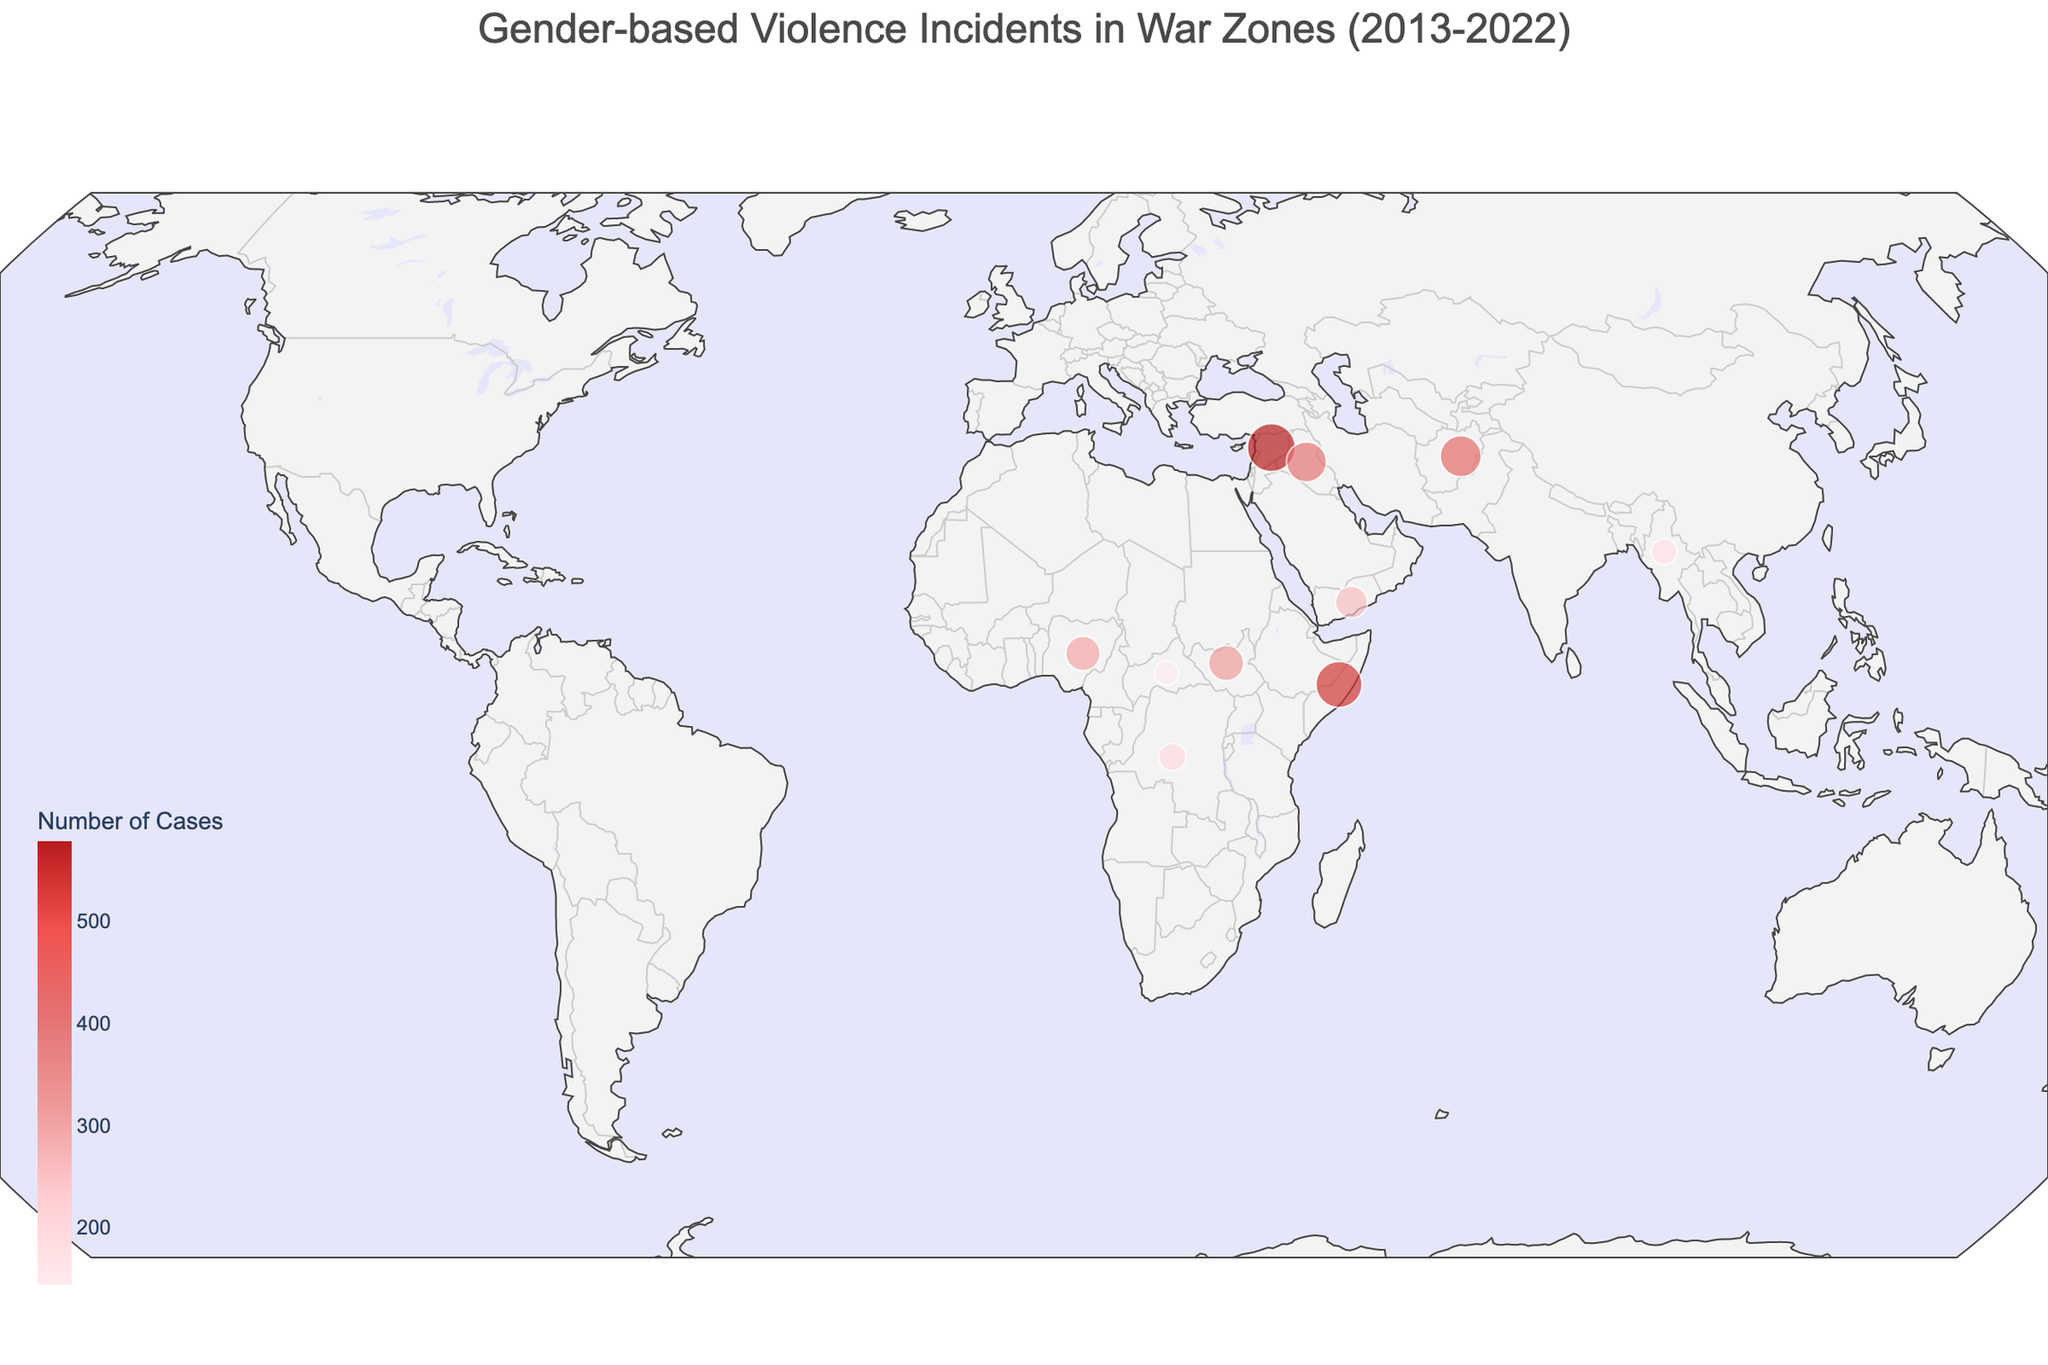What is the title of the figure? The title of the figure is usually found at the top in larger and bold font. In this case, it is "Gender-based Violence Incidents in War Zones (2013-2022)" as mentioned in the description.
Answer: Gender-based Violence Incidents in War Zones (2013-2022) Which country had the highest number of gender-based violence cases? On the figure, this can be identified by looking for the largest point or the darkest color indicating the highest number of cases. In this dataset, Somalia has the highest number of cases with 534 incidents related to Female Genital Mutilation.
Answer: Somalia Which year had the incident involving "Domestic Violence" and in which country did it occur? By hovering over the data points or looking at the annotations on the map, domestic violence incidents can be identified, and their corresponding year and country will be displayed. The dataset indicates that Domestic Violence was recorded in 2016 in South Sudan.
Answer: 2016, South Sudan Compare the number of cases in the Democratic Republic of Congo and Central African Republic. Which country had more cases, and by how many? By identifying the points for these countries and looking at the numbers or colors corresponding to the number of cases, the comparison can be made. The Democratic Republic of Congo had 189 cases, while Central African Republic had 145 cases. The difference is 44 cases.
Answer: Democratic Republic of Congo had 44 more cases Which incident type is indicated for Myanmar, and how many cases were reported in 2020? Hovering over or annotating the point for Myanmar on the map will provide the detailed information including the incident type and number of cases. In 2020, Myanmar had 167 cases of Rape as a Weapon of War.
Answer: Rape as Weapon of War, 167 cases Is there a geographic trend in the locations of gender-based violence incidents? By visually inspecting the map, one can notice whether the incidents are clustered in a particular region or spread out. In this dataset, incidents are concentrated prominently in countries of Africa and the Middle East.
Answer: Concentrated in Africa and the Middle East How many cases of "Sexual Violence" were reported in Syria, and in which year did it occur? By spotting Syria on the map and viewing its data point, you can find this information. Syria had 578 cases of Sexual Violence reported in 2015.
Answer: 578 cases, 2015 Which country experienced "Gender-based Persecution" and in what year? The map annotations or hover data will reveal this information. The dataset shows that Iraq experienced 401 cases of Gender-based Persecution in 2014.
Answer: Iraq, 2014 Calculate the total number of gender-based violence cases across all listed countries. By summing up the 'Number_of_Cases' from all the entries in the dataset: (578 + 423 + 312 + 189 + 256 + 167 + 401 + 534 + 298 + 145) = 3303.
Answer: 3303 cases 